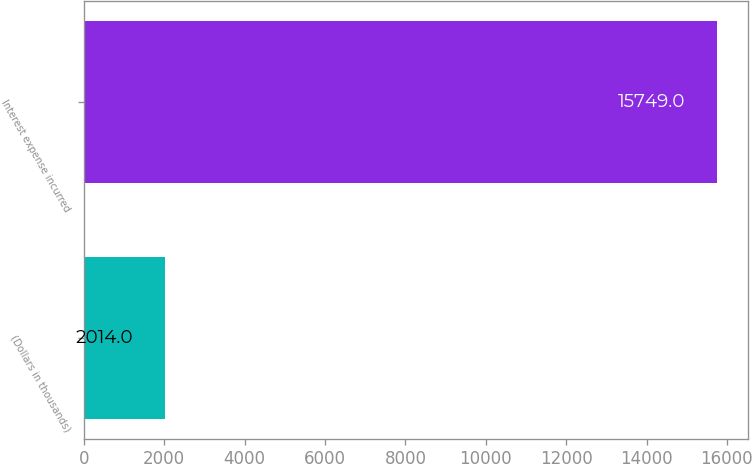Convert chart. <chart><loc_0><loc_0><loc_500><loc_500><bar_chart><fcel>(Dollars in thousands)<fcel>Interest expense incurred<nl><fcel>2014<fcel>15749<nl></chart> 